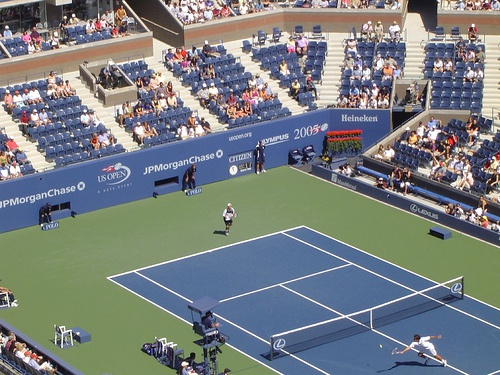Describe the objects in this image and their specific colors. I can see people in gray, lightgray, and darkgray tones, chair in gray, lightgray, and darkgray tones, people in gray, white, and darkgray tones, people in gray, black, and navy tones, and chair in gray, black, and navy tones in this image. 